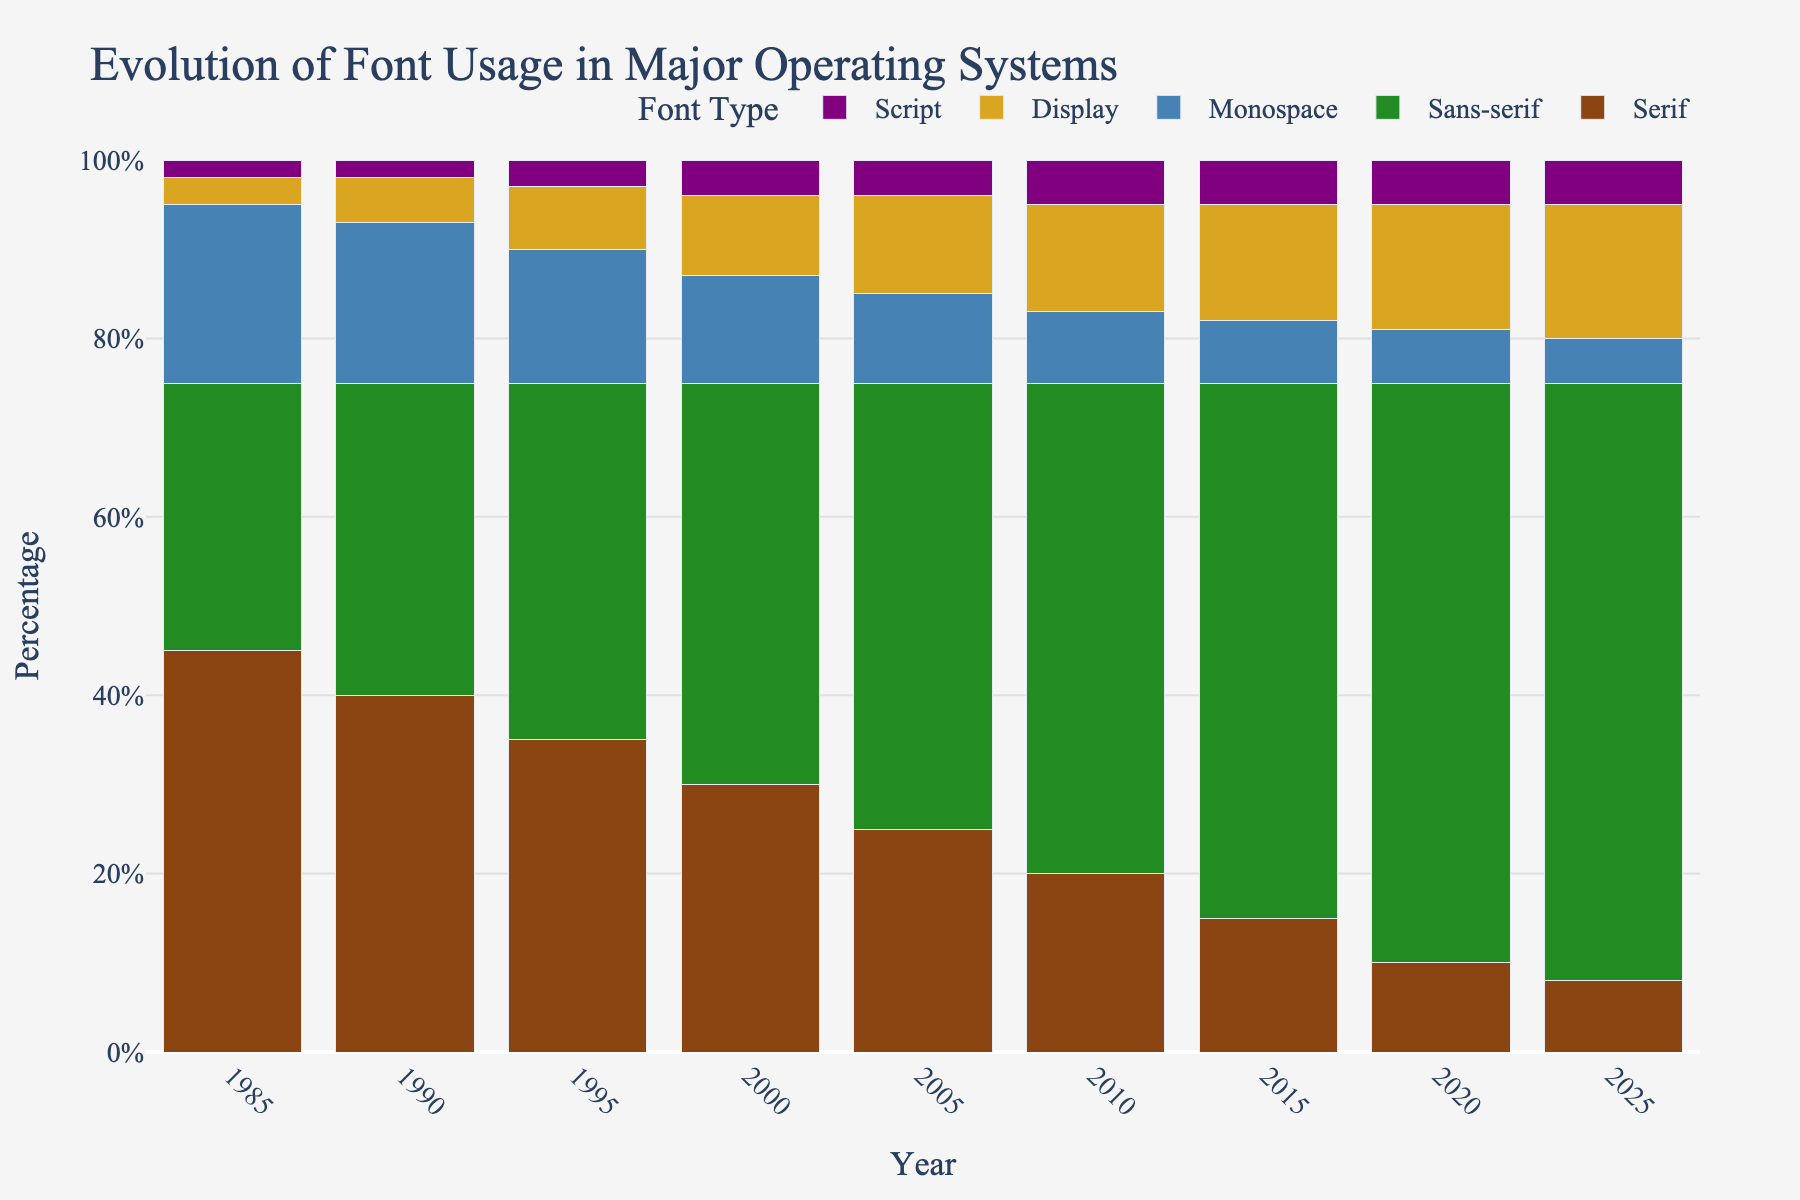How much has the usage of Sans-serif fonts increased from 1985 to 2025? In 1985, the usage of Sans-serif fonts was at 30%. By 2025, it increased to 67%. Therefore, the increase is 67% - 30% = 37%.
Answer: 37% Which font type has consistently decreased in usage from 1985 to 2025? By observing the trend for each typeface family, we see that Serif fonts have steadily decreased from 45% in 1985 to 8% in 2025.
Answer: Serif In which year did Monospace fonts have their highest usage and what was the percentage? By examining the Monospace series' values, we notice that the highest usage was in 1985 with 20%.
Answer: 1985, 20% Which font category saw the smallest change in usage percentage from 1985 to 2025? By comparing the beginning and end percentages for each font type, Script fonts changed from 2% in 1985 to 5% in 2025. This is an increase of only 3%, which is the smallest change.
Answer: Script What is the total percentage of Display and Script fonts combined in the year 2000? In 2000, Display fonts were at 9% and Script fonts were at 4%. Therefore, their combined total is 9% + 4% = 13%.
Answer: 13% How does the proportion of Serif to Sans-serif fonts change from 1990 to 2010? In 1990, the proportion of Serif to Sans-serif was 40/35 = 1.14. By 2010, it had changed to 20/55 = 0.36. So the proportion decreased from 1.14 to 0.36.
Answer: Decreased Which font type experienced the smallest percentage in usage during any given year? Script fonts in 1985 were only at 2%, which is the smallest percentage among all font types throughout the years.
Answer: Script, 1985 During which span of years did the usage of Sans-serif fonts surpass Serif fonts? Observing the trends, Sans-serif fonts surpassed Serif fonts between 1990 (Serif at 40%, Sans-serif at 35%) and 1995 (Serif at 35%, Sans-serif at 40%).
Answer: 1990-1995 